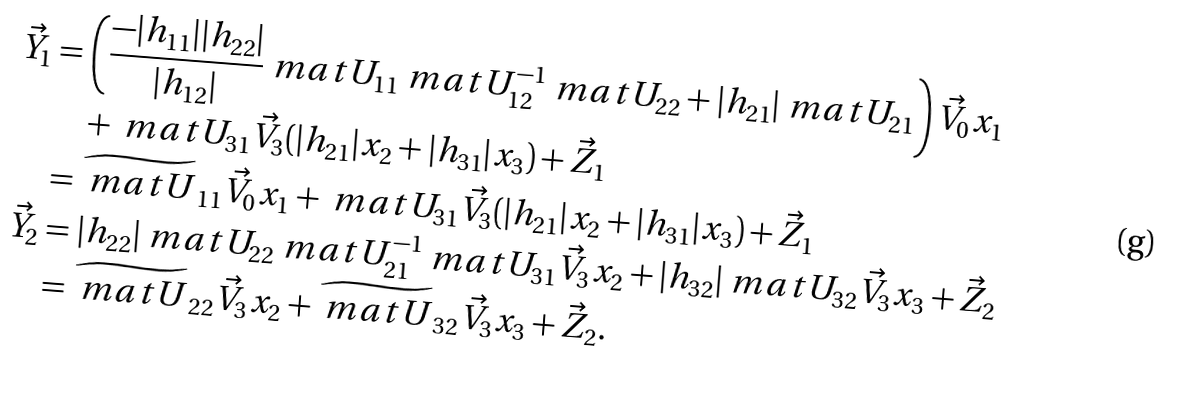<formula> <loc_0><loc_0><loc_500><loc_500>\vec { Y } _ { 1 } & = \left ( \frac { - | h _ { 1 1 } | | h _ { 2 2 } | } { | h _ { 1 2 } | } \ m a t { U } _ { 1 1 } \ m a t { U } _ { 1 2 } ^ { - 1 } \ m a t { U } _ { 2 2 } + | h _ { 2 1 } | \ m a t { U } _ { 2 1 } \right ) \vec { V } _ { 0 } x _ { 1 } \\ & \quad + \ m a t { U } _ { 3 1 } \vec { V } _ { 3 } ( | h _ { 2 1 } | x _ { 2 } + | h _ { 3 1 } | x _ { 3 } ) + \vec { Z } _ { 1 } \\ & = \widetilde { \ m a t { U } } _ { 1 1 } \vec { V } _ { 0 } x _ { 1 } + \ m a t { U } _ { 3 1 } \vec { V } _ { 3 } ( | h _ { 2 1 } | x _ { 2 } + | h _ { 3 1 } | x _ { 3 } ) + \vec { Z } _ { 1 } \\ \vec { Y } _ { 2 } & = | h _ { 2 2 } | \ m a t { U } _ { 2 2 } \ m a t { U } _ { 2 1 } ^ { - 1 } \ m a t { U } _ { 3 1 } \vec { V } _ { 3 } x _ { 2 } + | h _ { 3 2 } | \ m a t { U } _ { 3 2 } \vec { V } _ { 3 } x _ { 3 } + \vec { Z } _ { 2 } \\ & = \widetilde { \ m a t { U } } _ { 2 2 } \vec { V } _ { 3 } x _ { 2 } + \widetilde { \ m a t { U } } _ { 3 2 } \vec { V } _ { 3 } x _ { 3 } + \vec { Z } _ { 2 } .</formula> 